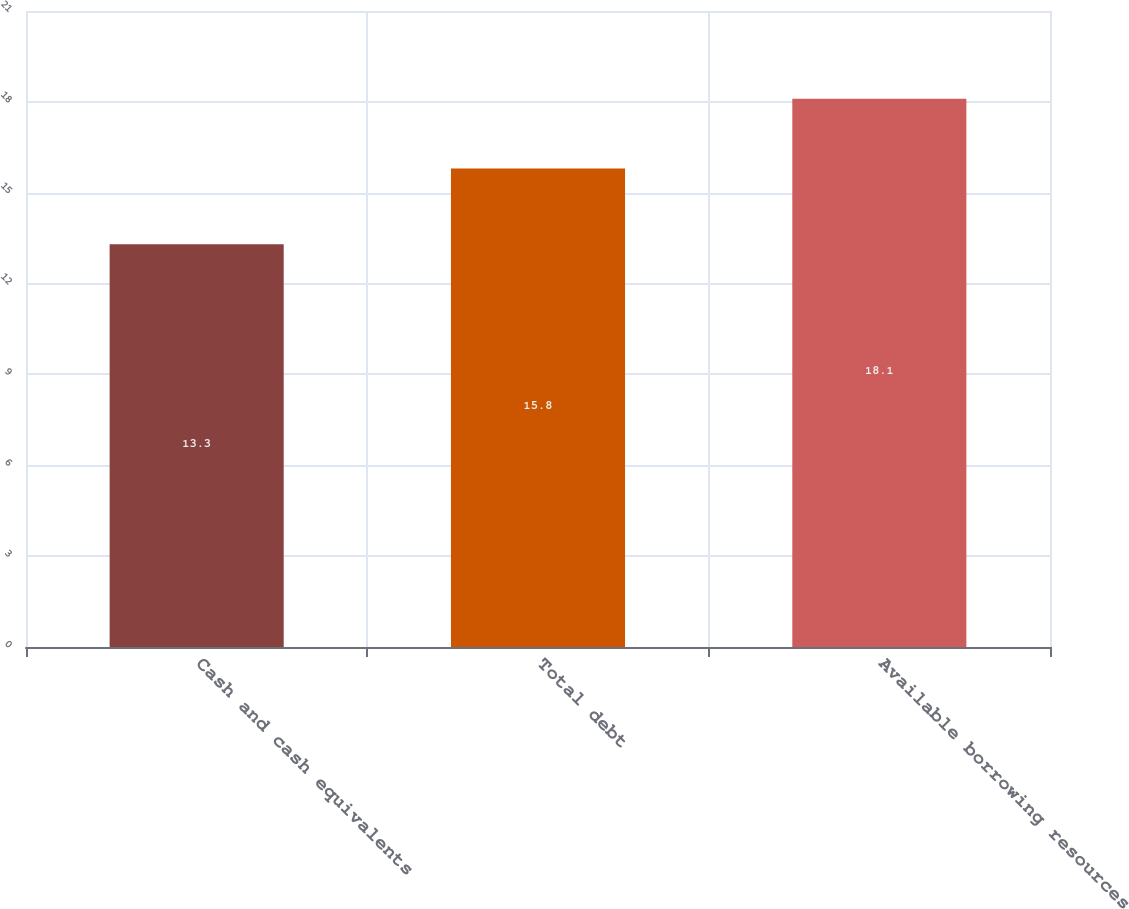<chart> <loc_0><loc_0><loc_500><loc_500><bar_chart><fcel>Cash and cash equivalents<fcel>Total debt<fcel>Available borrowing resources<nl><fcel>13.3<fcel>15.8<fcel>18.1<nl></chart> 